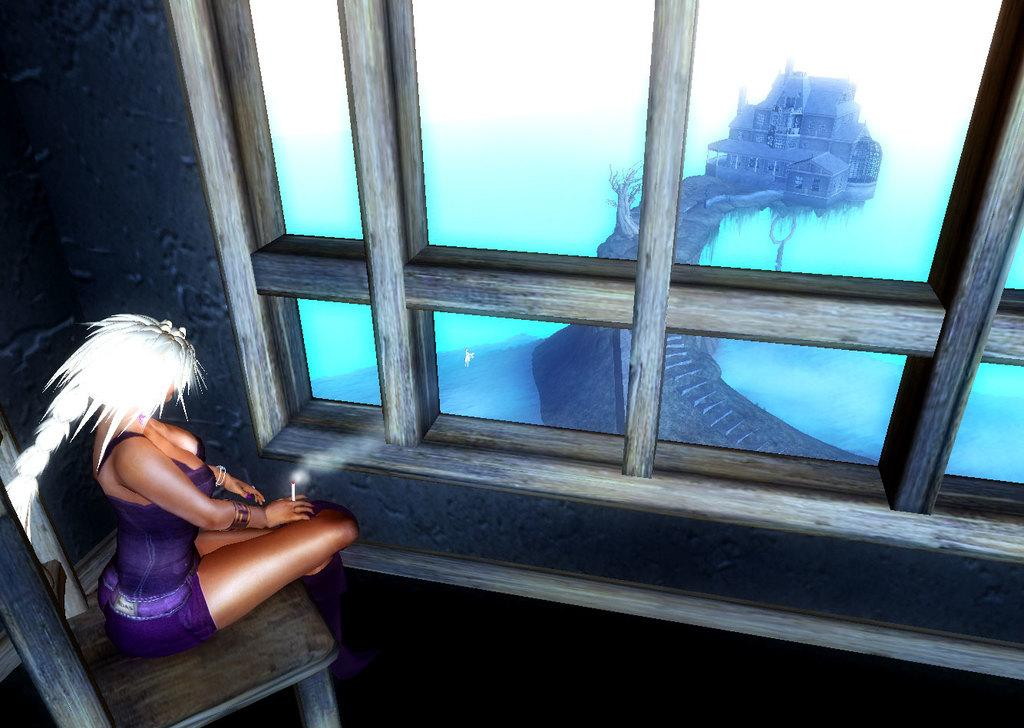Who is present in the image? There is a lady in the image. What is the lady doing in the image? The lady is sitting on a chair. What can be seen through the window in the image? A building and steps leading to the building are visible through the window. What type of wool is being used to pickle the lady in the image? There is no wool or pickling process present in the image; the lady is simply sitting on a chair. 